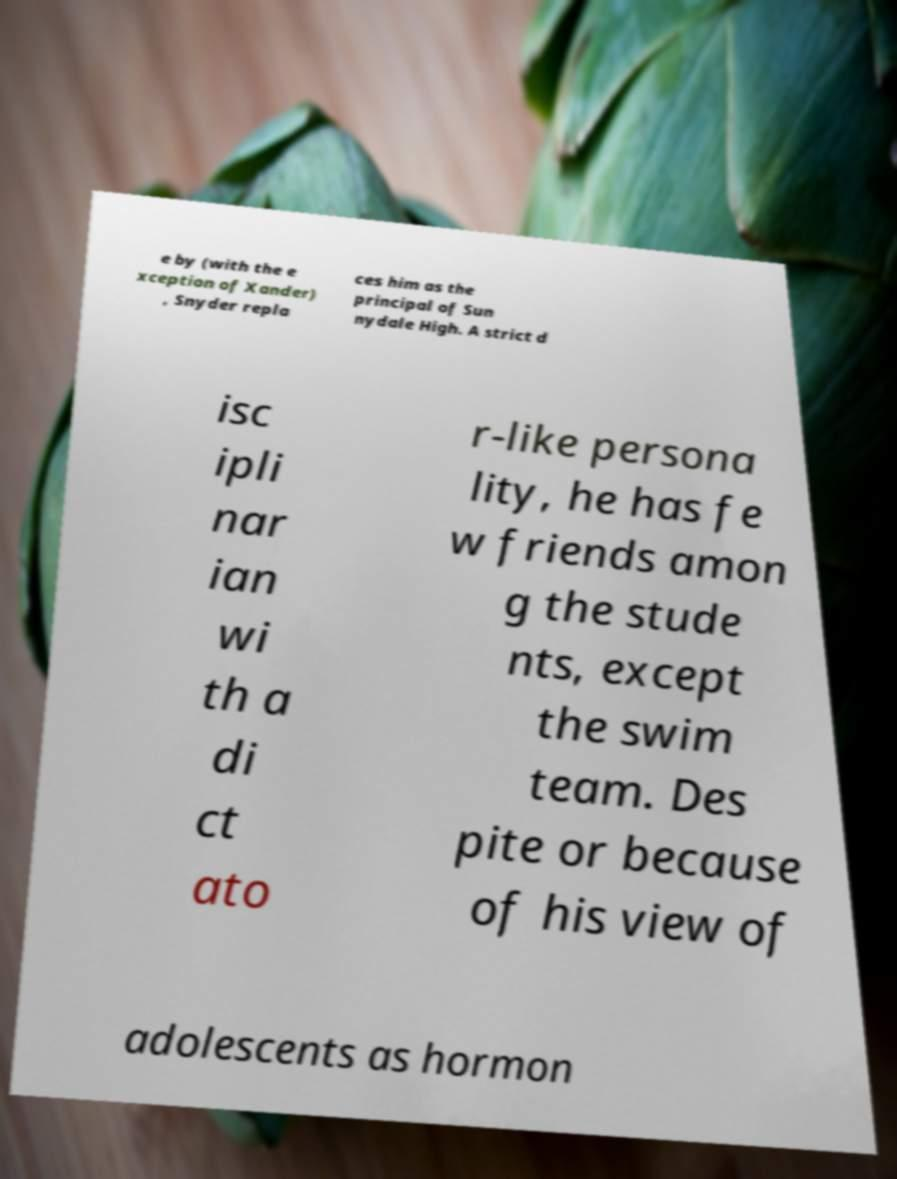Can you read and provide the text displayed in the image?This photo seems to have some interesting text. Can you extract and type it out for me? e by (with the e xception of Xander) , Snyder repla ces him as the principal of Sun nydale High. A strict d isc ipli nar ian wi th a di ct ato r-like persona lity, he has fe w friends amon g the stude nts, except the swim team. Des pite or because of his view of adolescents as hormon 